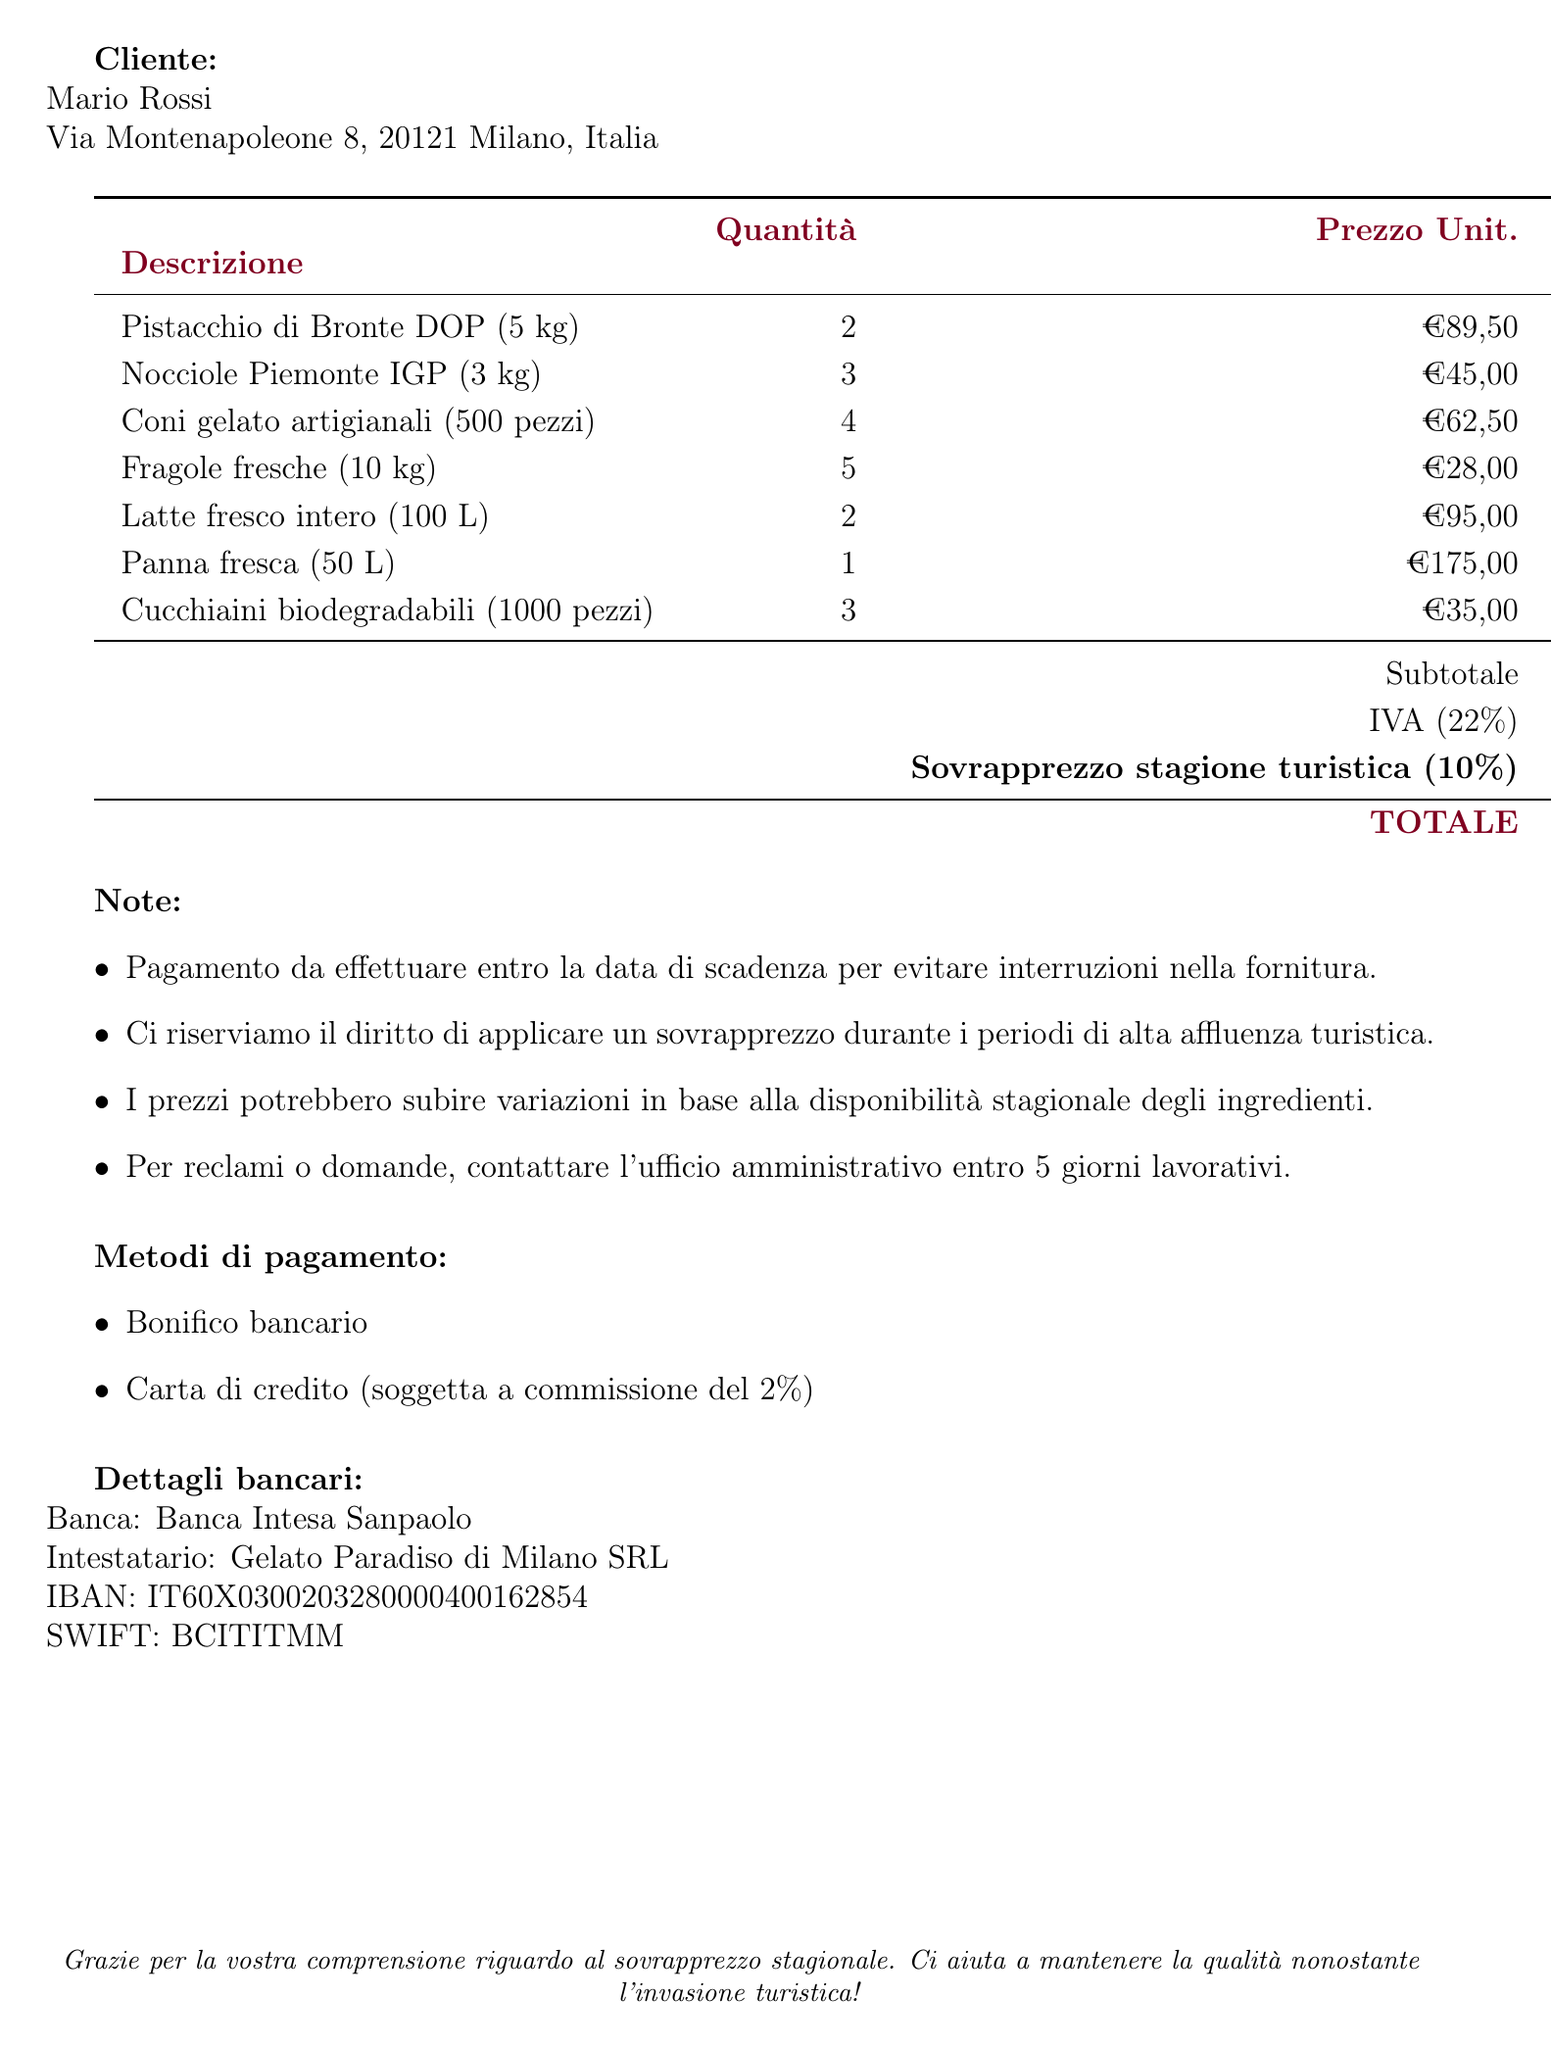what is the name of the company? The name of the company is stated at the beginning of the document.
Answer: Gelato Paradiso di Milano what is the invoice number? The invoice number is clearly marked on the document.
Answer: INV-2023-0587 who is the customer? The customer's name is listed under the client section.
Answer: Mario Rossi what is the due date for payment? The due date is explicitly mentioned in the document.
Answer: 29 luglio 2023 what is the surcharge amount? The surcharge amount is shown alongside the subtotal and tax.
Answer: €117,40 what is the total amount due? The total amount is indicated at the end of the invoice.
Answer: €1.549,68 how many kilograms of pistachio were ordered? The quantity of pistachio is specified in the item details.
Answer: 10 kg what percentage is the surcharge based on the subtotal? The surcharge percentage is mentioned in the description.
Answer: 10% which payment method incurs a fee? One of the payment methods has a noted fee associated.
Answer: Carta di credito 